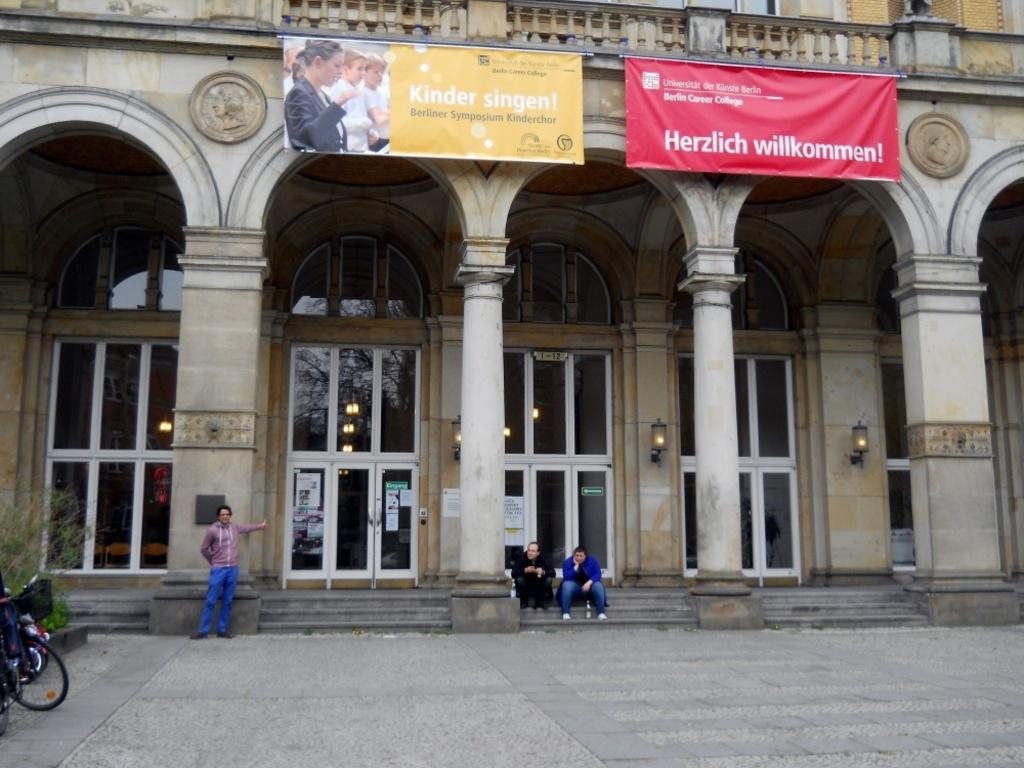How many people are in the image? There are three persons in the image. What object can be seen in the image that is typically used for transportation? There is a bicycle in the image. What type of living organism is present in the image? There is a plant in the image. What decorative items can be seen in the image? There are banners, lights, and posters in the image. What architectural features are visible in the image? There are doors, pillars, and a building in the image. What type of honey is being served in the image? There is no honey present in the image. How does the time change in the image? The image is a static representation and does not depict the passage of time. 